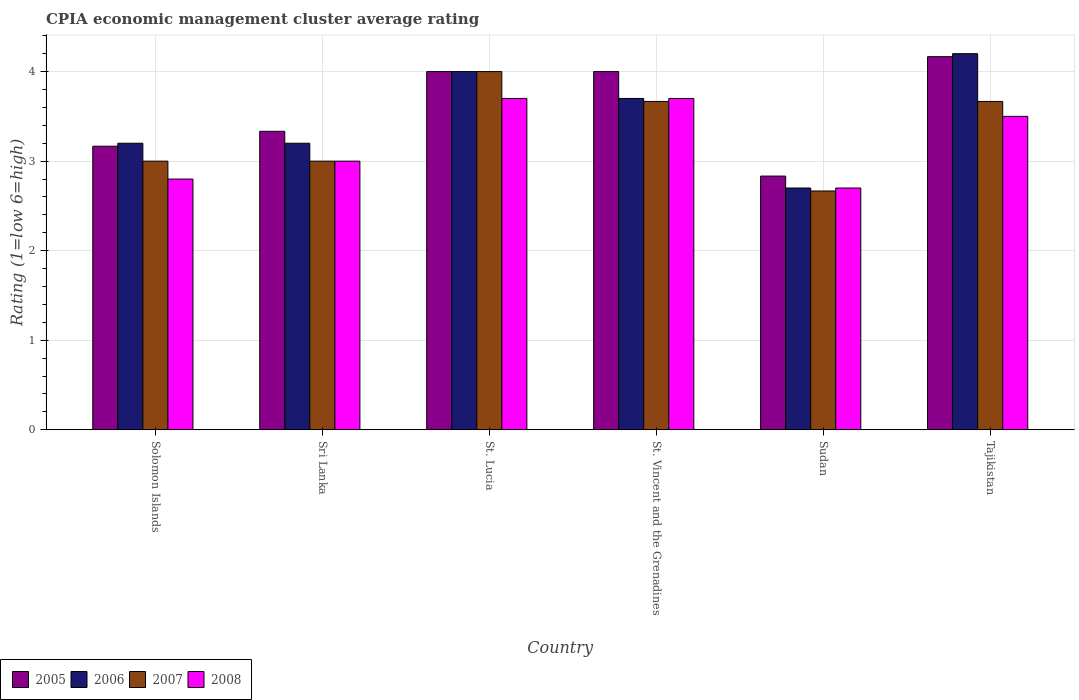Are the number of bars per tick equal to the number of legend labels?
Provide a short and direct response. Yes. How many bars are there on the 1st tick from the left?
Offer a terse response. 4. How many bars are there on the 5th tick from the right?
Make the answer very short. 4. What is the label of the 2nd group of bars from the left?
Provide a succinct answer. Sri Lanka. Across all countries, what is the maximum CPIA rating in 2008?
Offer a terse response. 3.7. Across all countries, what is the minimum CPIA rating in 2005?
Provide a short and direct response. 2.83. In which country was the CPIA rating in 2006 maximum?
Provide a short and direct response. Tajikistan. In which country was the CPIA rating in 2007 minimum?
Provide a short and direct response. Sudan. What is the difference between the CPIA rating in 2005 in St. Vincent and the Grenadines and that in Sudan?
Offer a very short reply. 1.17. What is the difference between the CPIA rating in 2005 in Sudan and the CPIA rating in 2008 in Sri Lanka?
Ensure brevity in your answer.  -0.17. What is the average CPIA rating in 2008 per country?
Give a very brief answer. 3.23. What is the difference between the CPIA rating of/in 2006 and CPIA rating of/in 2007 in St. Vincent and the Grenadines?
Offer a very short reply. 0.03. What is the ratio of the CPIA rating in 2008 in St. Lucia to that in St. Vincent and the Grenadines?
Provide a short and direct response. 1. What is the difference between the highest and the second highest CPIA rating in 2007?
Give a very brief answer. -0.33. Is the sum of the CPIA rating in 2007 in St. Lucia and Tajikistan greater than the maximum CPIA rating in 2005 across all countries?
Provide a short and direct response. Yes. Is it the case that in every country, the sum of the CPIA rating in 2005 and CPIA rating in 2006 is greater than the CPIA rating in 2007?
Your answer should be compact. Yes. How many bars are there?
Offer a very short reply. 24. Are all the bars in the graph horizontal?
Offer a terse response. No. What is the difference between two consecutive major ticks on the Y-axis?
Ensure brevity in your answer.  1. Where does the legend appear in the graph?
Offer a very short reply. Bottom left. How are the legend labels stacked?
Give a very brief answer. Horizontal. What is the title of the graph?
Offer a very short reply. CPIA economic management cluster average rating. What is the label or title of the X-axis?
Offer a terse response. Country. What is the label or title of the Y-axis?
Your answer should be compact. Rating (1=low 6=high). What is the Rating (1=low 6=high) of 2005 in Solomon Islands?
Ensure brevity in your answer.  3.17. What is the Rating (1=low 6=high) in 2006 in Solomon Islands?
Offer a very short reply. 3.2. What is the Rating (1=low 6=high) in 2008 in Solomon Islands?
Make the answer very short. 2.8. What is the Rating (1=low 6=high) in 2005 in Sri Lanka?
Ensure brevity in your answer.  3.33. What is the Rating (1=low 6=high) in 2008 in Sri Lanka?
Your answer should be compact. 3. What is the Rating (1=low 6=high) of 2005 in St. Lucia?
Make the answer very short. 4. What is the Rating (1=low 6=high) of 2006 in St. Lucia?
Make the answer very short. 4. What is the Rating (1=low 6=high) in 2008 in St. Lucia?
Your answer should be very brief. 3.7. What is the Rating (1=low 6=high) of 2005 in St. Vincent and the Grenadines?
Keep it short and to the point. 4. What is the Rating (1=low 6=high) in 2006 in St. Vincent and the Grenadines?
Ensure brevity in your answer.  3.7. What is the Rating (1=low 6=high) in 2007 in St. Vincent and the Grenadines?
Your answer should be very brief. 3.67. What is the Rating (1=low 6=high) in 2005 in Sudan?
Your answer should be very brief. 2.83. What is the Rating (1=low 6=high) in 2006 in Sudan?
Give a very brief answer. 2.7. What is the Rating (1=low 6=high) of 2007 in Sudan?
Your response must be concise. 2.67. What is the Rating (1=low 6=high) of 2005 in Tajikistan?
Offer a very short reply. 4.17. What is the Rating (1=low 6=high) in 2007 in Tajikistan?
Offer a very short reply. 3.67. Across all countries, what is the maximum Rating (1=low 6=high) in 2005?
Your response must be concise. 4.17. Across all countries, what is the maximum Rating (1=low 6=high) in 2008?
Your response must be concise. 3.7. Across all countries, what is the minimum Rating (1=low 6=high) in 2005?
Make the answer very short. 2.83. Across all countries, what is the minimum Rating (1=low 6=high) of 2006?
Provide a short and direct response. 2.7. Across all countries, what is the minimum Rating (1=low 6=high) of 2007?
Give a very brief answer. 2.67. Across all countries, what is the minimum Rating (1=low 6=high) of 2008?
Your answer should be compact. 2.7. What is the total Rating (1=low 6=high) in 2006 in the graph?
Provide a short and direct response. 21. What is the difference between the Rating (1=low 6=high) of 2005 in Solomon Islands and that in Sri Lanka?
Your answer should be very brief. -0.17. What is the difference between the Rating (1=low 6=high) in 2008 in Solomon Islands and that in Sri Lanka?
Offer a terse response. -0.2. What is the difference between the Rating (1=low 6=high) in 2005 in Solomon Islands and that in St. Vincent and the Grenadines?
Offer a terse response. -0.83. What is the difference between the Rating (1=low 6=high) in 2007 in Solomon Islands and that in St. Vincent and the Grenadines?
Your answer should be very brief. -0.67. What is the difference between the Rating (1=low 6=high) in 2005 in Solomon Islands and that in Sudan?
Offer a terse response. 0.33. What is the difference between the Rating (1=low 6=high) in 2006 in Solomon Islands and that in Sudan?
Offer a very short reply. 0.5. What is the difference between the Rating (1=low 6=high) in 2007 in Solomon Islands and that in Sudan?
Your response must be concise. 0.33. What is the difference between the Rating (1=low 6=high) of 2008 in Solomon Islands and that in Sudan?
Make the answer very short. 0.1. What is the difference between the Rating (1=low 6=high) in 2005 in Solomon Islands and that in Tajikistan?
Ensure brevity in your answer.  -1. What is the difference between the Rating (1=low 6=high) of 2007 in Solomon Islands and that in Tajikistan?
Offer a terse response. -0.67. What is the difference between the Rating (1=low 6=high) in 2008 in Solomon Islands and that in Tajikistan?
Make the answer very short. -0.7. What is the difference between the Rating (1=low 6=high) in 2005 in Sri Lanka and that in St. Lucia?
Your answer should be compact. -0.67. What is the difference between the Rating (1=low 6=high) of 2008 in Sri Lanka and that in St. Lucia?
Your answer should be compact. -0.7. What is the difference between the Rating (1=low 6=high) in 2005 in Sri Lanka and that in St. Vincent and the Grenadines?
Your answer should be compact. -0.67. What is the difference between the Rating (1=low 6=high) in 2007 in Sri Lanka and that in St. Vincent and the Grenadines?
Provide a short and direct response. -0.67. What is the difference between the Rating (1=low 6=high) in 2005 in Sri Lanka and that in Sudan?
Provide a succinct answer. 0.5. What is the difference between the Rating (1=low 6=high) in 2006 in Sri Lanka and that in Sudan?
Make the answer very short. 0.5. What is the difference between the Rating (1=low 6=high) of 2007 in Sri Lanka and that in Sudan?
Your answer should be very brief. 0.33. What is the difference between the Rating (1=low 6=high) of 2005 in Sri Lanka and that in Tajikistan?
Provide a succinct answer. -0.83. What is the difference between the Rating (1=low 6=high) in 2007 in Sri Lanka and that in Tajikistan?
Provide a short and direct response. -0.67. What is the difference between the Rating (1=low 6=high) in 2006 in St. Lucia and that in St. Vincent and the Grenadines?
Keep it short and to the point. 0.3. What is the difference between the Rating (1=low 6=high) in 2007 in St. Lucia and that in St. Vincent and the Grenadines?
Provide a succinct answer. 0.33. What is the difference between the Rating (1=low 6=high) in 2008 in St. Lucia and that in St. Vincent and the Grenadines?
Offer a very short reply. 0. What is the difference between the Rating (1=low 6=high) in 2006 in St. Lucia and that in Sudan?
Give a very brief answer. 1.3. What is the difference between the Rating (1=low 6=high) in 2007 in St. Lucia and that in Sudan?
Your answer should be very brief. 1.33. What is the difference between the Rating (1=low 6=high) of 2006 in St. Lucia and that in Tajikistan?
Your answer should be very brief. -0.2. What is the difference between the Rating (1=low 6=high) in 2008 in St. Lucia and that in Tajikistan?
Offer a very short reply. 0.2. What is the difference between the Rating (1=low 6=high) in 2006 in St. Vincent and the Grenadines and that in Sudan?
Provide a short and direct response. 1. What is the difference between the Rating (1=low 6=high) of 2005 in St. Vincent and the Grenadines and that in Tajikistan?
Offer a terse response. -0.17. What is the difference between the Rating (1=low 6=high) in 2005 in Sudan and that in Tajikistan?
Your response must be concise. -1.33. What is the difference between the Rating (1=low 6=high) in 2006 in Sudan and that in Tajikistan?
Offer a terse response. -1.5. What is the difference between the Rating (1=low 6=high) of 2007 in Sudan and that in Tajikistan?
Keep it short and to the point. -1. What is the difference between the Rating (1=low 6=high) of 2005 in Solomon Islands and the Rating (1=low 6=high) of 2006 in Sri Lanka?
Ensure brevity in your answer.  -0.03. What is the difference between the Rating (1=low 6=high) in 2007 in Solomon Islands and the Rating (1=low 6=high) in 2008 in Sri Lanka?
Keep it short and to the point. 0. What is the difference between the Rating (1=low 6=high) in 2005 in Solomon Islands and the Rating (1=low 6=high) in 2006 in St. Lucia?
Ensure brevity in your answer.  -0.83. What is the difference between the Rating (1=low 6=high) of 2005 in Solomon Islands and the Rating (1=low 6=high) of 2007 in St. Lucia?
Offer a very short reply. -0.83. What is the difference between the Rating (1=low 6=high) of 2005 in Solomon Islands and the Rating (1=low 6=high) of 2008 in St. Lucia?
Your answer should be compact. -0.53. What is the difference between the Rating (1=low 6=high) in 2006 in Solomon Islands and the Rating (1=low 6=high) in 2007 in St. Lucia?
Offer a terse response. -0.8. What is the difference between the Rating (1=low 6=high) in 2006 in Solomon Islands and the Rating (1=low 6=high) in 2008 in St. Lucia?
Offer a very short reply. -0.5. What is the difference between the Rating (1=low 6=high) of 2007 in Solomon Islands and the Rating (1=low 6=high) of 2008 in St. Lucia?
Keep it short and to the point. -0.7. What is the difference between the Rating (1=low 6=high) in 2005 in Solomon Islands and the Rating (1=low 6=high) in 2006 in St. Vincent and the Grenadines?
Offer a very short reply. -0.53. What is the difference between the Rating (1=low 6=high) of 2005 in Solomon Islands and the Rating (1=low 6=high) of 2007 in St. Vincent and the Grenadines?
Provide a succinct answer. -0.5. What is the difference between the Rating (1=low 6=high) in 2005 in Solomon Islands and the Rating (1=low 6=high) in 2008 in St. Vincent and the Grenadines?
Give a very brief answer. -0.53. What is the difference between the Rating (1=low 6=high) in 2006 in Solomon Islands and the Rating (1=low 6=high) in 2007 in St. Vincent and the Grenadines?
Give a very brief answer. -0.47. What is the difference between the Rating (1=low 6=high) in 2005 in Solomon Islands and the Rating (1=low 6=high) in 2006 in Sudan?
Offer a very short reply. 0.47. What is the difference between the Rating (1=low 6=high) of 2005 in Solomon Islands and the Rating (1=low 6=high) of 2008 in Sudan?
Offer a terse response. 0.47. What is the difference between the Rating (1=low 6=high) in 2006 in Solomon Islands and the Rating (1=low 6=high) in 2007 in Sudan?
Your answer should be very brief. 0.53. What is the difference between the Rating (1=low 6=high) of 2007 in Solomon Islands and the Rating (1=low 6=high) of 2008 in Sudan?
Provide a short and direct response. 0.3. What is the difference between the Rating (1=low 6=high) in 2005 in Solomon Islands and the Rating (1=low 6=high) in 2006 in Tajikistan?
Offer a terse response. -1.03. What is the difference between the Rating (1=low 6=high) in 2005 in Solomon Islands and the Rating (1=low 6=high) in 2008 in Tajikistan?
Provide a succinct answer. -0.33. What is the difference between the Rating (1=low 6=high) of 2006 in Solomon Islands and the Rating (1=low 6=high) of 2007 in Tajikistan?
Provide a succinct answer. -0.47. What is the difference between the Rating (1=low 6=high) of 2006 in Solomon Islands and the Rating (1=low 6=high) of 2008 in Tajikistan?
Keep it short and to the point. -0.3. What is the difference between the Rating (1=low 6=high) in 2007 in Solomon Islands and the Rating (1=low 6=high) in 2008 in Tajikistan?
Offer a terse response. -0.5. What is the difference between the Rating (1=low 6=high) of 2005 in Sri Lanka and the Rating (1=low 6=high) of 2006 in St. Lucia?
Your answer should be very brief. -0.67. What is the difference between the Rating (1=low 6=high) of 2005 in Sri Lanka and the Rating (1=low 6=high) of 2007 in St. Lucia?
Your answer should be very brief. -0.67. What is the difference between the Rating (1=low 6=high) of 2005 in Sri Lanka and the Rating (1=low 6=high) of 2008 in St. Lucia?
Provide a succinct answer. -0.37. What is the difference between the Rating (1=low 6=high) of 2006 in Sri Lanka and the Rating (1=low 6=high) of 2007 in St. Lucia?
Provide a succinct answer. -0.8. What is the difference between the Rating (1=low 6=high) in 2006 in Sri Lanka and the Rating (1=low 6=high) in 2008 in St. Lucia?
Your response must be concise. -0.5. What is the difference between the Rating (1=low 6=high) of 2005 in Sri Lanka and the Rating (1=low 6=high) of 2006 in St. Vincent and the Grenadines?
Offer a terse response. -0.37. What is the difference between the Rating (1=low 6=high) of 2005 in Sri Lanka and the Rating (1=low 6=high) of 2007 in St. Vincent and the Grenadines?
Offer a terse response. -0.33. What is the difference between the Rating (1=low 6=high) of 2005 in Sri Lanka and the Rating (1=low 6=high) of 2008 in St. Vincent and the Grenadines?
Your response must be concise. -0.37. What is the difference between the Rating (1=low 6=high) of 2006 in Sri Lanka and the Rating (1=low 6=high) of 2007 in St. Vincent and the Grenadines?
Provide a succinct answer. -0.47. What is the difference between the Rating (1=low 6=high) of 2005 in Sri Lanka and the Rating (1=low 6=high) of 2006 in Sudan?
Provide a short and direct response. 0.63. What is the difference between the Rating (1=low 6=high) in 2005 in Sri Lanka and the Rating (1=low 6=high) in 2007 in Sudan?
Your answer should be compact. 0.67. What is the difference between the Rating (1=low 6=high) in 2005 in Sri Lanka and the Rating (1=low 6=high) in 2008 in Sudan?
Offer a very short reply. 0.63. What is the difference between the Rating (1=low 6=high) of 2006 in Sri Lanka and the Rating (1=low 6=high) of 2007 in Sudan?
Your response must be concise. 0.53. What is the difference between the Rating (1=low 6=high) in 2006 in Sri Lanka and the Rating (1=low 6=high) in 2008 in Sudan?
Your response must be concise. 0.5. What is the difference between the Rating (1=low 6=high) of 2007 in Sri Lanka and the Rating (1=low 6=high) of 2008 in Sudan?
Make the answer very short. 0.3. What is the difference between the Rating (1=low 6=high) of 2005 in Sri Lanka and the Rating (1=low 6=high) of 2006 in Tajikistan?
Provide a short and direct response. -0.87. What is the difference between the Rating (1=low 6=high) in 2005 in Sri Lanka and the Rating (1=low 6=high) in 2007 in Tajikistan?
Keep it short and to the point. -0.33. What is the difference between the Rating (1=low 6=high) of 2006 in Sri Lanka and the Rating (1=low 6=high) of 2007 in Tajikistan?
Offer a very short reply. -0.47. What is the difference between the Rating (1=low 6=high) of 2005 in St. Lucia and the Rating (1=low 6=high) of 2006 in St. Vincent and the Grenadines?
Ensure brevity in your answer.  0.3. What is the difference between the Rating (1=low 6=high) of 2005 in St. Lucia and the Rating (1=low 6=high) of 2007 in St. Vincent and the Grenadines?
Make the answer very short. 0.33. What is the difference between the Rating (1=low 6=high) in 2005 in St. Lucia and the Rating (1=low 6=high) in 2008 in St. Vincent and the Grenadines?
Keep it short and to the point. 0.3. What is the difference between the Rating (1=low 6=high) of 2007 in St. Lucia and the Rating (1=low 6=high) of 2008 in St. Vincent and the Grenadines?
Your answer should be compact. 0.3. What is the difference between the Rating (1=low 6=high) of 2005 in St. Lucia and the Rating (1=low 6=high) of 2007 in Sudan?
Your response must be concise. 1.33. What is the difference between the Rating (1=low 6=high) of 2005 in St. Lucia and the Rating (1=low 6=high) of 2008 in Sudan?
Offer a terse response. 1.3. What is the difference between the Rating (1=low 6=high) in 2007 in St. Lucia and the Rating (1=low 6=high) in 2008 in Sudan?
Offer a terse response. 1.3. What is the difference between the Rating (1=low 6=high) of 2005 in St. Lucia and the Rating (1=low 6=high) of 2007 in Tajikistan?
Make the answer very short. 0.33. What is the difference between the Rating (1=low 6=high) of 2005 in St. Lucia and the Rating (1=low 6=high) of 2008 in Tajikistan?
Your answer should be compact. 0.5. What is the difference between the Rating (1=low 6=high) of 2005 in St. Vincent and the Grenadines and the Rating (1=low 6=high) of 2007 in Sudan?
Ensure brevity in your answer.  1.33. What is the difference between the Rating (1=low 6=high) in 2007 in St. Vincent and the Grenadines and the Rating (1=low 6=high) in 2008 in Sudan?
Ensure brevity in your answer.  0.97. What is the difference between the Rating (1=low 6=high) of 2005 in St. Vincent and the Grenadines and the Rating (1=low 6=high) of 2006 in Tajikistan?
Provide a succinct answer. -0.2. What is the difference between the Rating (1=low 6=high) in 2006 in St. Vincent and the Grenadines and the Rating (1=low 6=high) in 2007 in Tajikistan?
Your answer should be very brief. 0.03. What is the difference between the Rating (1=low 6=high) of 2006 in St. Vincent and the Grenadines and the Rating (1=low 6=high) of 2008 in Tajikistan?
Offer a very short reply. 0.2. What is the difference between the Rating (1=low 6=high) in 2005 in Sudan and the Rating (1=low 6=high) in 2006 in Tajikistan?
Ensure brevity in your answer.  -1.37. What is the difference between the Rating (1=low 6=high) of 2005 in Sudan and the Rating (1=low 6=high) of 2007 in Tajikistan?
Make the answer very short. -0.83. What is the difference between the Rating (1=low 6=high) of 2006 in Sudan and the Rating (1=low 6=high) of 2007 in Tajikistan?
Provide a succinct answer. -0.97. What is the difference between the Rating (1=low 6=high) of 2007 in Sudan and the Rating (1=low 6=high) of 2008 in Tajikistan?
Offer a terse response. -0.83. What is the average Rating (1=low 6=high) of 2005 per country?
Your response must be concise. 3.58. What is the average Rating (1=low 6=high) in 2006 per country?
Keep it short and to the point. 3.5. What is the average Rating (1=low 6=high) of 2008 per country?
Your answer should be very brief. 3.23. What is the difference between the Rating (1=low 6=high) in 2005 and Rating (1=low 6=high) in 2006 in Solomon Islands?
Provide a short and direct response. -0.03. What is the difference between the Rating (1=low 6=high) in 2005 and Rating (1=low 6=high) in 2007 in Solomon Islands?
Your answer should be very brief. 0.17. What is the difference between the Rating (1=low 6=high) in 2005 and Rating (1=low 6=high) in 2008 in Solomon Islands?
Provide a short and direct response. 0.37. What is the difference between the Rating (1=low 6=high) of 2006 and Rating (1=low 6=high) of 2007 in Solomon Islands?
Offer a very short reply. 0.2. What is the difference between the Rating (1=low 6=high) of 2005 and Rating (1=low 6=high) of 2006 in Sri Lanka?
Provide a succinct answer. 0.13. What is the difference between the Rating (1=low 6=high) of 2005 and Rating (1=low 6=high) of 2007 in Sri Lanka?
Ensure brevity in your answer.  0.33. What is the difference between the Rating (1=low 6=high) of 2005 and Rating (1=low 6=high) of 2008 in Sri Lanka?
Offer a terse response. 0.33. What is the difference between the Rating (1=low 6=high) of 2005 and Rating (1=low 6=high) of 2006 in St. Lucia?
Provide a succinct answer. 0. What is the difference between the Rating (1=low 6=high) in 2005 and Rating (1=low 6=high) in 2007 in St. Lucia?
Provide a short and direct response. 0. What is the difference between the Rating (1=low 6=high) in 2005 and Rating (1=low 6=high) in 2008 in St. Lucia?
Your response must be concise. 0.3. What is the difference between the Rating (1=low 6=high) of 2006 and Rating (1=low 6=high) of 2007 in St. Lucia?
Give a very brief answer. 0. What is the difference between the Rating (1=low 6=high) in 2007 and Rating (1=low 6=high) in 2008 in St. Lucia?
Your response must be concise. 0.3. What is the difference between the Rating (1=low 6=high) of 2005 and Rating (1=low 6=high) of 2008 in St. Vincent and the Grenadines?
Provide a succinct answer. 0.3. What is the difference between the Rating (1=low 6=high) in 2006 and Rating (1=low 6=high) in 2007 in St. Vincent and the Grenadines?
Give a very brief answer. 0.03. What is the difference between the Rating (1=low 6=high) in 2006 and Rating (1=low 6=high) in 2008 in St. Vincent and the Grenadines?
Offer a very short reply. 0. What is the difference between the Rating (1=low 6=high) in 2007 and Rating (1=low 6=high) in 2008 in St. Vincent and the Grenadines?
Provide a succinct answer. -0.03. What is the difference between the Rating (1=low 6=high) of 2005 and Rating (1=low 6=high) of 2006 in Sudan?
Offer a very short reply. 0.13. What is the difference between the Rating (1=low 6=high) in 2005 and Rating (1=low 6=high) in 2007 in Sudan?
Offer a very short reply. 0.17. What is the difference between the Rating (1=low 6=high) of 2005 and Rating (1=low 6=high) of 2008 in Sudan?
Make the answer very short. 0.13. What is the difference between the Rating (1=low 6=high) of 2006 and Rating (1=low 6=high) of 2008 in Sudan?
Offer a terse response. 0. What is the difference between the Rating (1=low 6=high) in 2007 and Rating (1=low 6=high) in 2008 in Sudan?
Provide a succinct answer. -0.03. What is the difference between the Rating (1=low 6=high) in 2005 and Rating (1=low 6=high) in 2006 in Tajikistan?
Provide a succinct answer. -0.03. What is the difference between the Rating (1=low 6=high) of 2006 and Rating (1=low 6=high) of 2007 in Tajikistan?
Your answer should be very brief. 0.53. What is the difference between the Rating (1=low 6=high) of 2006 and Rating (1=low 6=high) of 2008 in Tajikistan?
Make the answer very short. 0.7. What is the ratio of the Rating (1=low 6=high) of 2006 in Solomon Islands to that in Sri Lanka?
Keep it short and to the point. 1. What is the ratio of the Rating (1=low 6=high) in 2008 in Solomon Islands to that in Sri Lanka?
Your answer should be compact. 0.93. What is the ratio of the Rating (1=low 6=high) of 2005 in Solomon Islands to that in St. Lucia?
Offer a very short reply. 0.79. What is the ratio of the Rating (1=low 6=high) of 2006 in Solomon Islands to that in St. Lucia?
Offer a very short reply. 0.8. What is the ratio of the Rating (1=low 6=high) in 2008 in Solomon Islands to that in St. Lucia?
Keep it short and to the point. 0.76. What is the ratio of the Rating (1=low 6=high) in 2005 in Solomon Islands to that in St. Vincent and the Grenadines?
Ensure brevity in your answer.  0.79. What is the ratio of the Rating (1=low 6=high) in 2006 in Solomon Islands to that in St. Vincent and the Grenadines?
Your response must be concise. 0.86. What is the ratio of the Rating (1=low 6=high) in 2007 in Solomon Islands to that in St. Vincent and the Grenadines?
Provide a succinct answer. 0.82. What is the ratio of the Rating (1=low 6=high) of 2008 in Solomon Islands to that in St. Vincent and the Grenadines?
Provide a succinct answer. 0.76. What is the ratio of the Rating (1=low 6=high) of 2005 in Solomon Islands to that in Sudan?
Your answer should be very brief. 1.12. What is the ratio of the Rating (1=low 6=high) of 2006 in Solomon Islands to that in Sudan?
Offer a terse response. 1.19. What is the ratio of the Rating (1=low 6=high) in 2008 in Solomon Islands to that in Sudan?
Give a very brief answer. 1.04. What is the ratio of the Rating (1=low 6=high) of 2005 in Solomon Islands to that in Tajikistan?
Keep it short and to the point. 0.76. What is the ratio of the Rating (1=low 6=high) of 2006 in Solomon Islands to that in Tajikistan?
Offer a very short reply. 0.76. What is the ratio of the Rating (1=low 6=high) of 2007 in Solomon Islands to that in Tajikistan?
Offer a very short reply. 0.82. What is the ratio of the Rating (1=low 6=high) in 2005 in Sri Lanka to that in St. Lucia?
Your answer should be very brief. 0.83. What is the ratio of the Rating (1=low 6=high) of 2006 in Sri Lanka to that in St. Lucia?
Keep it short and to the point. 0.8. What is the ratio of the Rating (1=low 6=high) in 2007 in Sri Lanka to that in St. Lucia?
Ensure brevity in your answer.  0.75. What is the ratio of the Rating (1=low 6=high) of 2008 in Sri Lanka to that in St. Lucia?
Your answer should be very brief. 0.81. What is the ratio of the Rating (1=low 6=high) of 2006 in Sri Lanka to that in St. Vincent and the Grenadines?
Make the answer very short. 0.86. What is the ratio of the Rating (1=low 6=high) of 2007 in Sri Lanka to that in St. Vincent and the Grenadines?
Your answer should be compact. 0.82. What is the ratio of the Rating (1=low 6=high) of 2008 in Sri Lanka to that in St. Vincent and the Grenadines?
Offer a very short reply. 0.81. What is the ratio of the Rating (1=low 6=high) of 2005 in Sri Lanka to that in Sudan?
Provide a succinct answer. 1.18. What is the ratio of the Rating (1=low 6=high) of 2006 in Sri Lanka to that in Sudan?
Ensure brevity in your answer.  1.19. What is the ratio of the Rating (1=low 6=high) of 2008 in Sri Lanka to that in Sudan?
Your response must be concise. 1.11. What is the ratio of the Rating (1=low 6=high) in 2006 in Sri Lanka to that in Tajikistan?
Keep it short and to the point. 0.76. What is the ratio of the Rating (1=low 6=high) of 2007 in Sri Lanka to that in Tajikistan?
Offer a very short reply. 0.82. What is the ratio of the Rating (1=low 6=high) of 2008 in Sri Lanka to that in Tajikistan?
Your response must be concise. 0.86. What is the ratio of the Rating (1=low 6=high) of 2005 in St. Lucia to that in St. Vincent and the Grenadines?
Offer a terse response. 1. What is the ratio of the Rating (1=low 6=high) in 2006 in St. Lucia to that in St. Vincent and the Grenadines?
Give a very brief answer. 1.08. What is the ratio of the Rating (1=low 6=high) of 2008 in St. Lucia to that in St. Vincent and the Grenadines?
Ensure brevity in your answer.  1. What is the ratio of the Rating (1=low 6=high) in 2005 in St. Lucia to that in Sudan?
Provide a succinct answer. 1.41. What is the ratio of the Rating (1=low 6=high) in 2006 in St. Lucia to that in Sudan?
Provide a succinct answer. 1.48. What is the ratio of the Rating (1=low 6=high) in 2007 in St. Lucia to that in Sudan?
Keep it short and to the point. 1.5. What is the ratio of the Rating (1=low 6=high) of 2008 in St. Lucia to that in Sudan?
Offer a very short reply. 1.37. What is the ratio of the Rating (1=low 6=high) in 2005 in St. Lucia to that in Tajikistan?
Offer a very short reply. 0.96. What is the ratio of the Rating (1=low 6=high) of 2006 in St. Lucia to that in Tajikistan?
Your answer should be very brief. 0.95. What is the ratio of the Rating (1=low 6=high) in 2008 in St. Lucia to that in Tajikistan?
Keep it short and to the point. 1.06. What is the ratio of the Rating (1=low 6=high) in 2005 in St. Vincent and the Grenadines to that in Sudan?
Keep it short and to the point. 1.41. What is the ratio of the Rating (1=low 6=high) of 2006 in St. Vincent and the Grenadines to that in Sudan?
Provide a succinct answer. 1.37. What is the ratio of the Rating (1=low 6=high) of 2007 in St. Vincent and the Grenadines to that in Sudan?
Your answer should be very brief. 1.38. What is the ratio of the Rating (1=low 6=high) in 2008 in St. Vincent and the Grenadines to that in Sudan?
Your response must be concise. 1.37. What is the ratio of the Rating (1=low 6=high) of 2005 in St. Vincent and the Grenadines to that in Tajikistan?
Your answer should be very brief. 0.96. What is the ratio of the Rating (1=low 6=high) of 2006 in St. Vincent and the Grenadines to that in Tajikistan?
Your answer should be compact. 0.88. What is the ratio of the Rating (1=low 6=high) in 2007 in St. Vincent and the Grenadines to that in Tajikistan?
Ensure brevity in your answer.  1. What is the ratio of the Rating (1=low 6=high) in 2008 in St. Vincent and the Grenadines to that in Tajikistan?
Make the answer very short. 1.06. What is the ratio of the Rating (1=low 6=high) of 2005 in Sudan to that in Tajikistan?
Make the answer very short. 0.68. What is the ratio of the Rating (1=low 6=high) of 2006 in Sudan to that in Tajikistan?
Your response must be concise. 0.64. What is the ratio of the Rating (1=low 6=high) in 2007 in Sudan to that in Tajikistan?
Ensure brevity in your answer.  0.73. What is the ratio of the Rating (1=low 6=high) of 2008 in Sudan to that in Tajikistan?
Ensure brevity in your answer.  0.77. What is the difference between the highest and the second highest Rating (1=low 6=high) in 2006?
Offer a terse response. 0.2. What is the difference between the highest and the second highest Rating (1=low 6=high) of 2007?
Offer a very short reply. 0.33. 